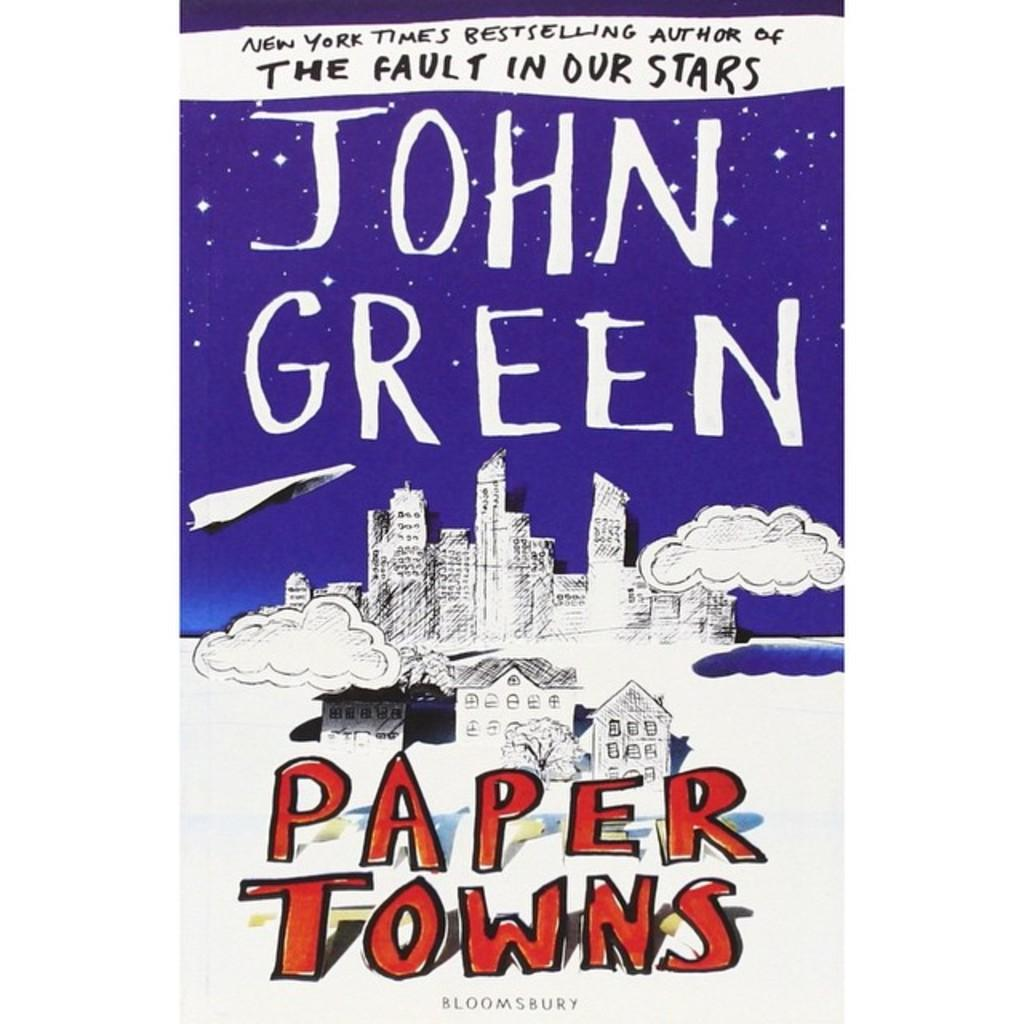<image>
Offer a succinct explanation of the picture presented. A view of the book cover for Paper Towns. 